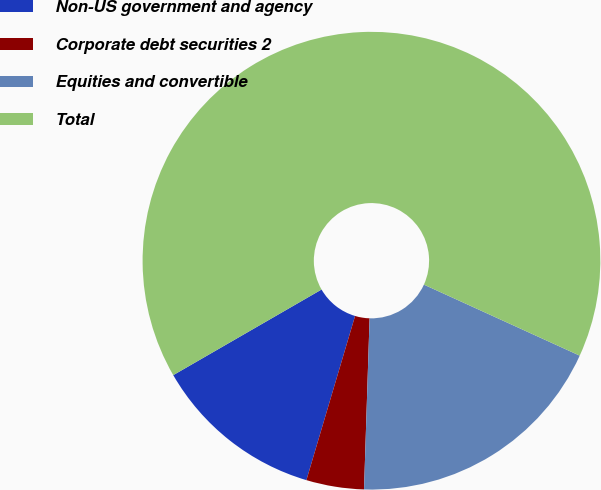<chart> <loc_0><loc_0><loc_500><loc_500><pie_chart><fcel>Non-US government and agency<fcel>Corporate debt securities 2<fcel>Equities and convertible<fcel>Total<nl><fcel>12.08%<fcel>4.07%<fcel>18.71%<fcel>65.14%<nl></chart> 